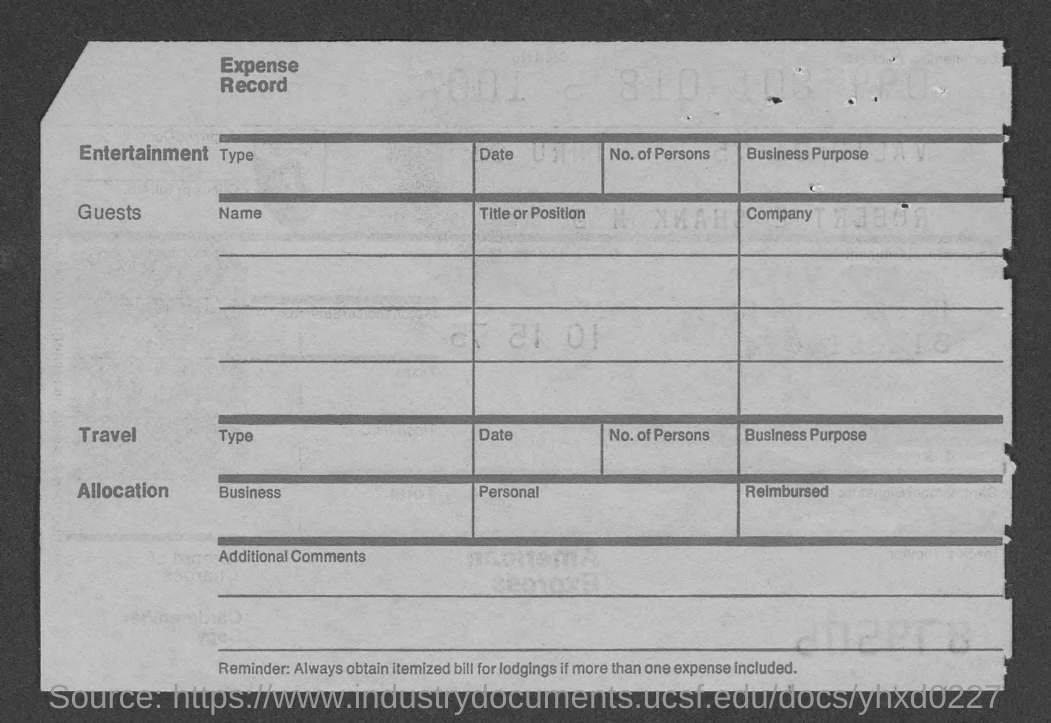Mention a couple of crucial points in this snapshot. The title of the record is "Expense Record. 